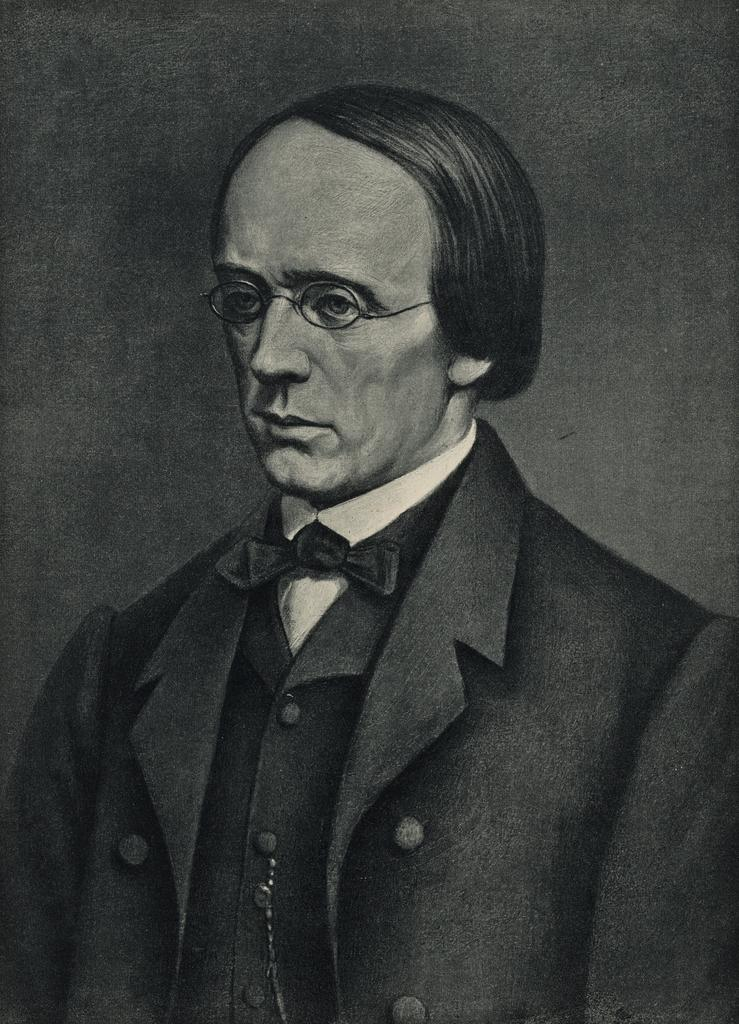What type of artwork is depicted in the image? The image is a painting. Can you describe the main subject of the painting? There is a man in the painting. What accessory is the man wearing in the painting? The man is wearing glasses. What can be seen in the background of the painting? There is a wall in the background of the painting. What type of fork can be seen in the painting? There is no fork present in the painting; it is a painting of a man wearing glasses with a wall in the background. 